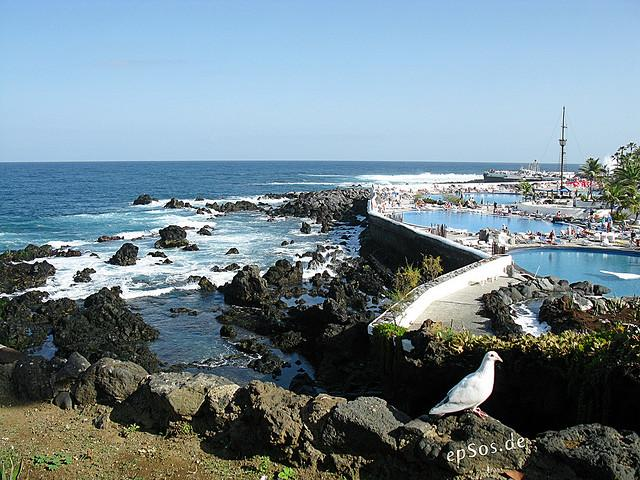What venue is shown on the right? Please explain your reasoning. resort area. The area looks tropical. 